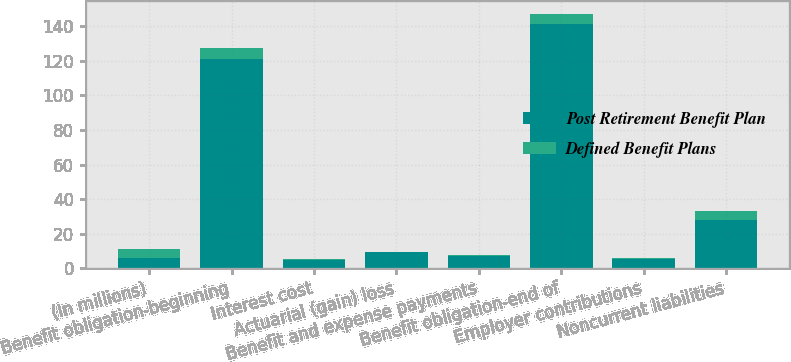<chart> <loc_0><loc_0><loc_500><loc_500><stacked_bar_chart><ecel><fcel>(In millions)<fcel>Benefit obligation-beginning<fcel>Interest cost<fcel>Actuarial (gain) loss<fcel>Benefit and expense payments<fcel>Benefit obligation-end of<fcel>Employer contributions<fcel>Noncurrent liabilities<nl><fcel>Post Retirement Benefit Plan<fcel>5.7<fcel>121<fcel>4.9<fcel>9.2<fcel>7<fcel>141.1<fcel>5.5<fcel>28<nl><fcel>Defined Benefit Plans<fcel>5.7<fcel>6.2<fcel>0.3<fcel>0.1<fcel>0.5<fcel>5.9<fcel>0.5<fcel>5.4<nl></chart> 